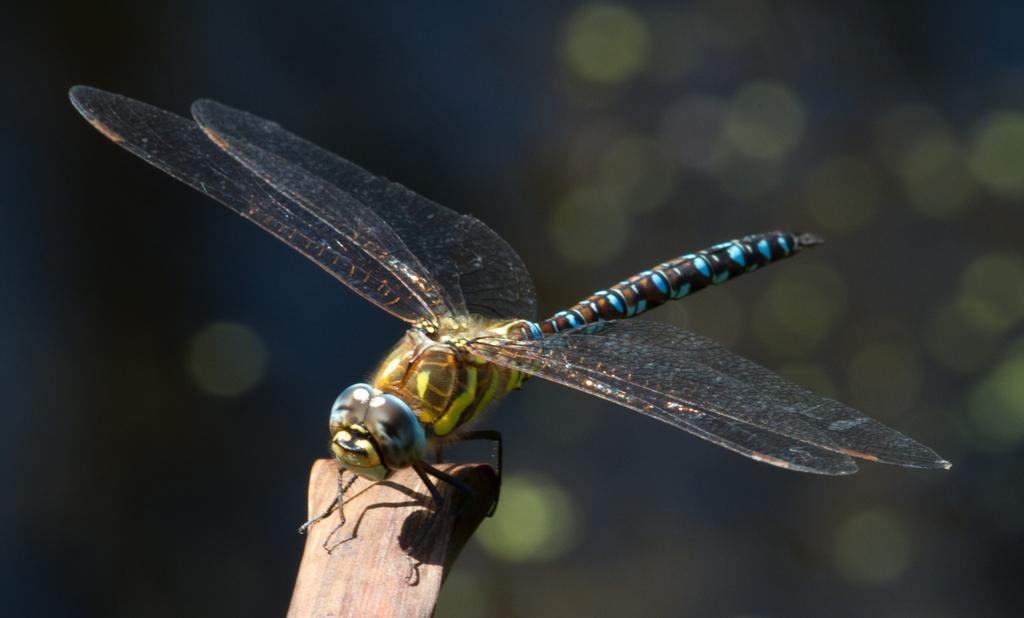What type of insect is present in the image? There is a dragonfly in the image. What type of loss or error is depicted in the image? There is no loss or error depicted in the image; it features a dragonfly. What type of adjustment is needed to improve the image? The image does not require any adjustment, as it is a clear image of a dragonfly. 